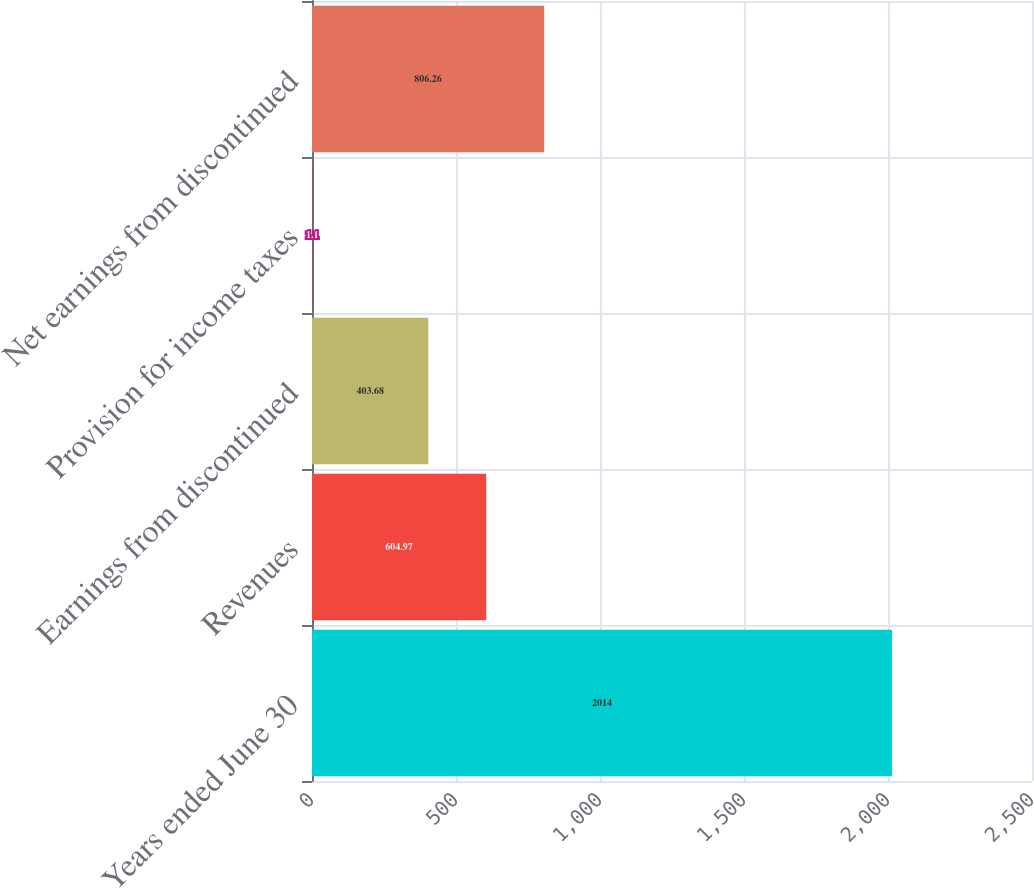Convert chart. <chart><loc_0><loc_0><loc_500><loc_500><bar_chart><fcel>Years ended June 30<fcel>Revenues<fcel>Earnings from discontinued<fcel>Provision for income taxes<fcel>Net earnings from discontinued<nl><fcel>2014<fcel>604.97<fcel>403.68<fcel>1.1<fcel>806.26<nl></chart> 